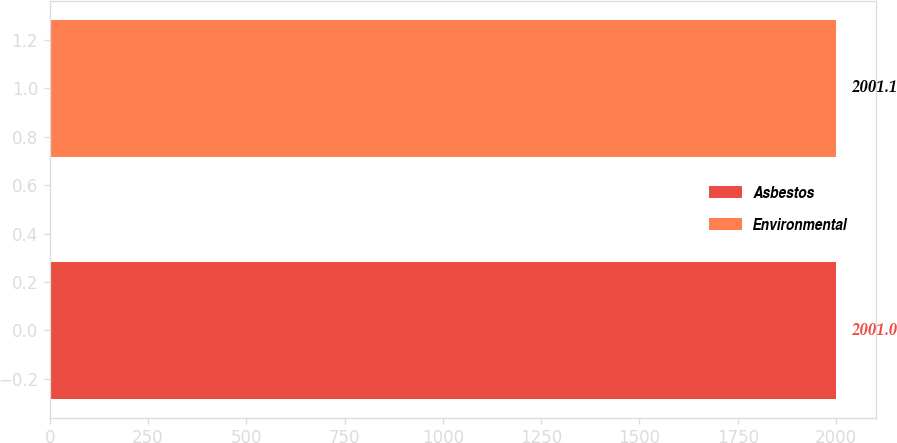Convert chart. <chart><loc_0><loc_0><loc_500><loc_500><bar_chart><fcel>Asbestos<fcel>Environmental<nl><fcel>2001<fcel>2001.1<nl></chart> 